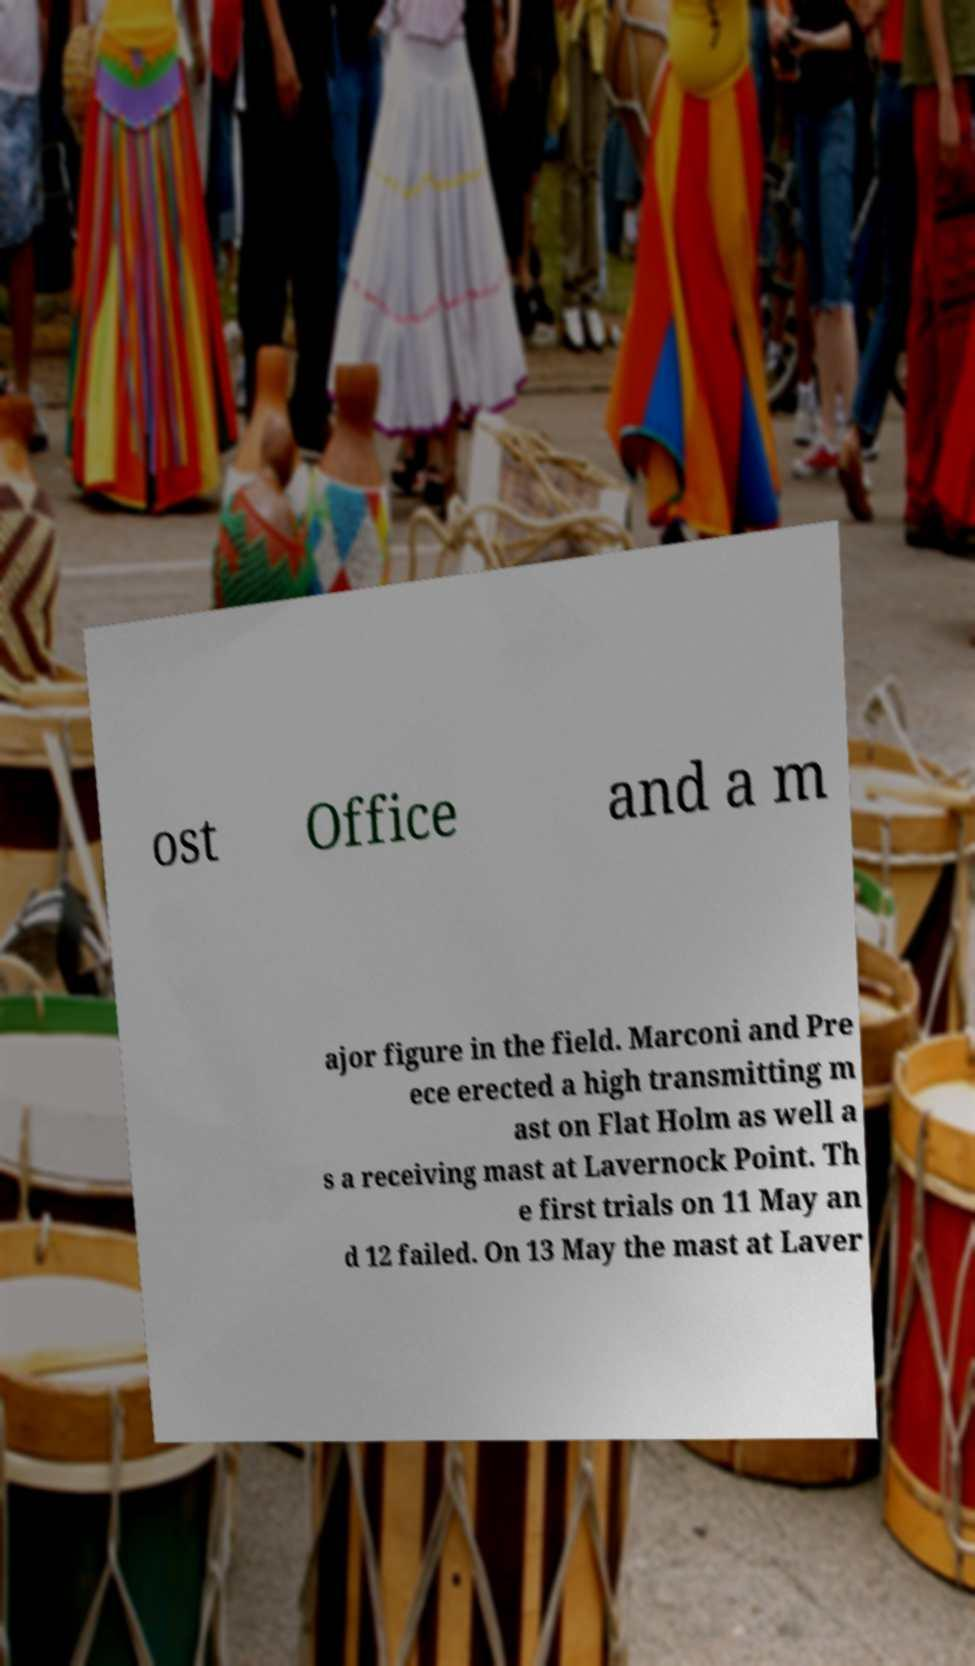What messages or text are displayed in this image? I need them in a readable, typed format. ost Office and a m ajor figure in the field. Marconi and Pre ece erected a high transmitting m ast on Flat Holm as well a s a receiving mast at Lavernock Point. Th e first trials on 11 May an d 12 failed. On 13 May the mast at Laver 